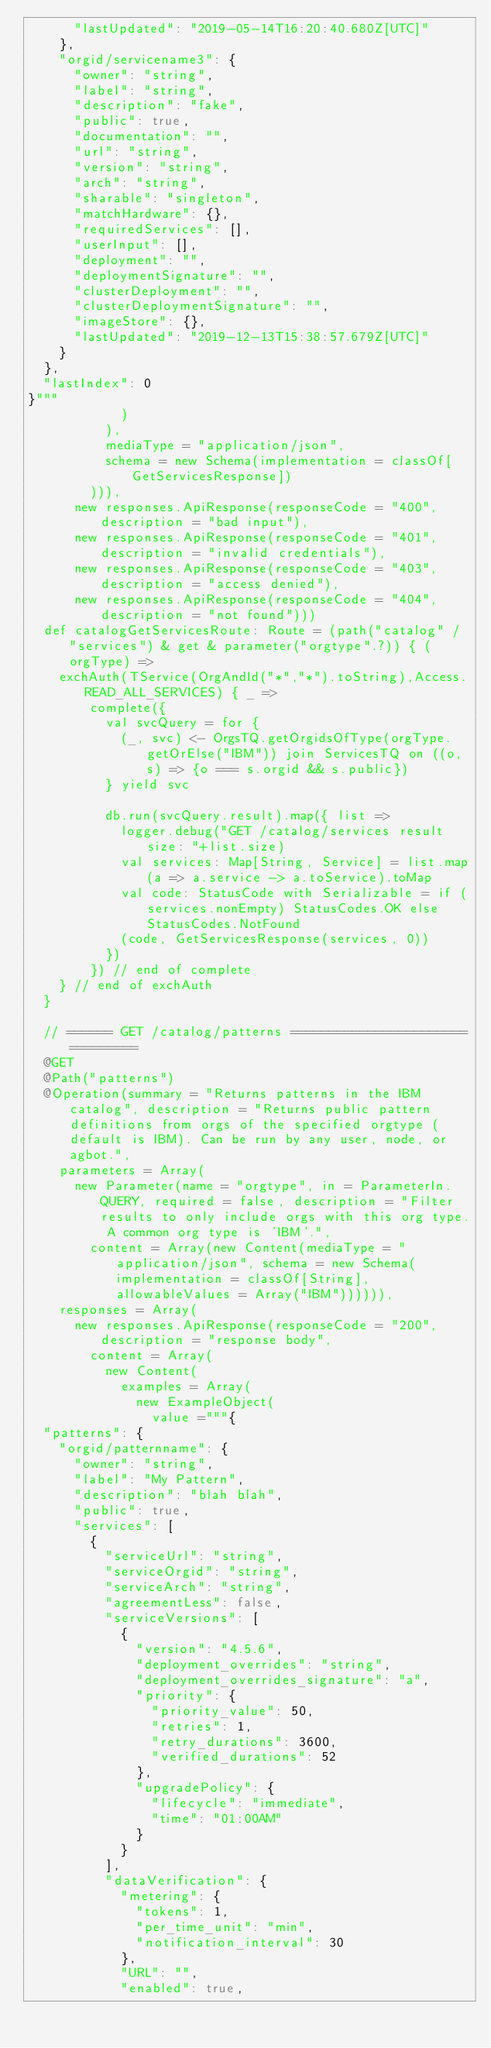Convert code to text. <code><loc_0><loc_0><loc_500><loc_500><_Scala_>      "lastUpdated": "2019-05-14T16:20:40.680Z[UTC]"
    },
    "orgid/servicename3": {
      "owner": "string",
      "label": "string",
      "description": "fake",
      "public": true,
      "documentation": "",
      "url": "string",
      "version": "string",
      "arch": "string",
      "sharable": "singleton",
      "matchHardware": {},
      "requiredServices": [],
      "userInput": [],
      "deployment": "",
      "deploymentSignature": "",
      "clusterDeployment": "",
      "clusterDeploymentSignature": "",
      "imageStore": {},
      "lastUpdated": "2019-12-13T15:38:57.679Z[UTC]"
    }
  },
  "lastIndex": 0
}"""
            )
          ),
          mediaType = "application/json",
          schema = new Schema(implementation = classOf[GetServicesResponse])
        ))),
      new responses.ApiResponse(responseCode = "400", description = "bad input"),
      new responses.ApiResponse(responseCode = "401", description = "invalid credentials"),
      new responses.ApiResponse(responseCode = "403", description = "access denied"),
      new responses.ApiResponse(responseCode = "404", description = "not found")))
  def catalogGetServicesRoute: Route = (path("catalog" / "services") & get & parameter("orgtype".?)) { (orgType) =>
    exchAuth(TService(OrgAndId("*","*").toString),Access.READ_ALL_SERVICES) { _ =>
        complete({
          val svcQuery = for {
            (_, svc) <- OrgsTQ.getOrgidsOfType(orgType.getOrElse("IBM")) join ServicesTQ on ((o, s) => {o === s.orgid && s.public})
          } yield svc

          db.run(svcQuery.result).map({ list =>
            logger.debug("GET /catalog/services result size: "+list.size)
            val services: Map[String, Service] = list.map(a => a.service -> a.toService).toMap
            val code: StatusCode with Serializable = if (services.nonEmpty) StatusCodes.OK else StatusCodes.NotFound
            (code, GetServicesResponse(services, 0))
          })
        }) // end of complete
    } // end of exchAuth
  }

  // ====== GET /catalog/patterns ================================
  @GET
  @Path("patterns")
  @Operation(summary = "Returns patterns in the IBM catalog", description = "Returns public pattern definitions from orgs of the specified orgtype (default is IBM). Can be run by any user, node, or agbot.",
    parameters = Array(
      new Parameter(name = "orgtype", in = ParameterIn.QUERY, required = false, description = "Filter results to only include orgs with this org type. A common org type is 'IBM'.",
        content = Array(new Content(mediaType = "application/json", schema = new Schema(implementation = classOf[String], allowableValues = Array("IBM")))))),
    responses = Array(
      new responses.ApiResponse(responseCode = "200", description = "response body",
        content = Array(
          new Content(
            examples = Array(
              new ExampleObject(
                value ="""{
  "patterns": {
    "orgid/patternname": {
      "owner": "string",
      "label": "My Pattern",
      "description": "blah blah",
      "public": true,
      "services": [
        {
          "serviceUrl": "string",
          "serviceOrgid": "string",
          "serviceArch": "string",
          "agreementLess": false,
          "serviceVersions": [
            {
              "version": "4.5.6",
              "deployment_overrides": "string",
              "deployment_overrides_signature": "a",
              "priority": {
                "priority_value": 50,
                "retries": 1,
                "retry_durations": 3600,
                "verified_durations": 52
              },
              "upgradePolicy": {
                "lifecycle": "immediate",
                "time": "01:00AM"
              }
            }
          ],
          "dataVerification": {
            "metering": {
              "tokens": 1,
              "per_time_unit": "min",
              "notification_interval": 30
            },
            "URL": "",
            "enabled": true,</code> 